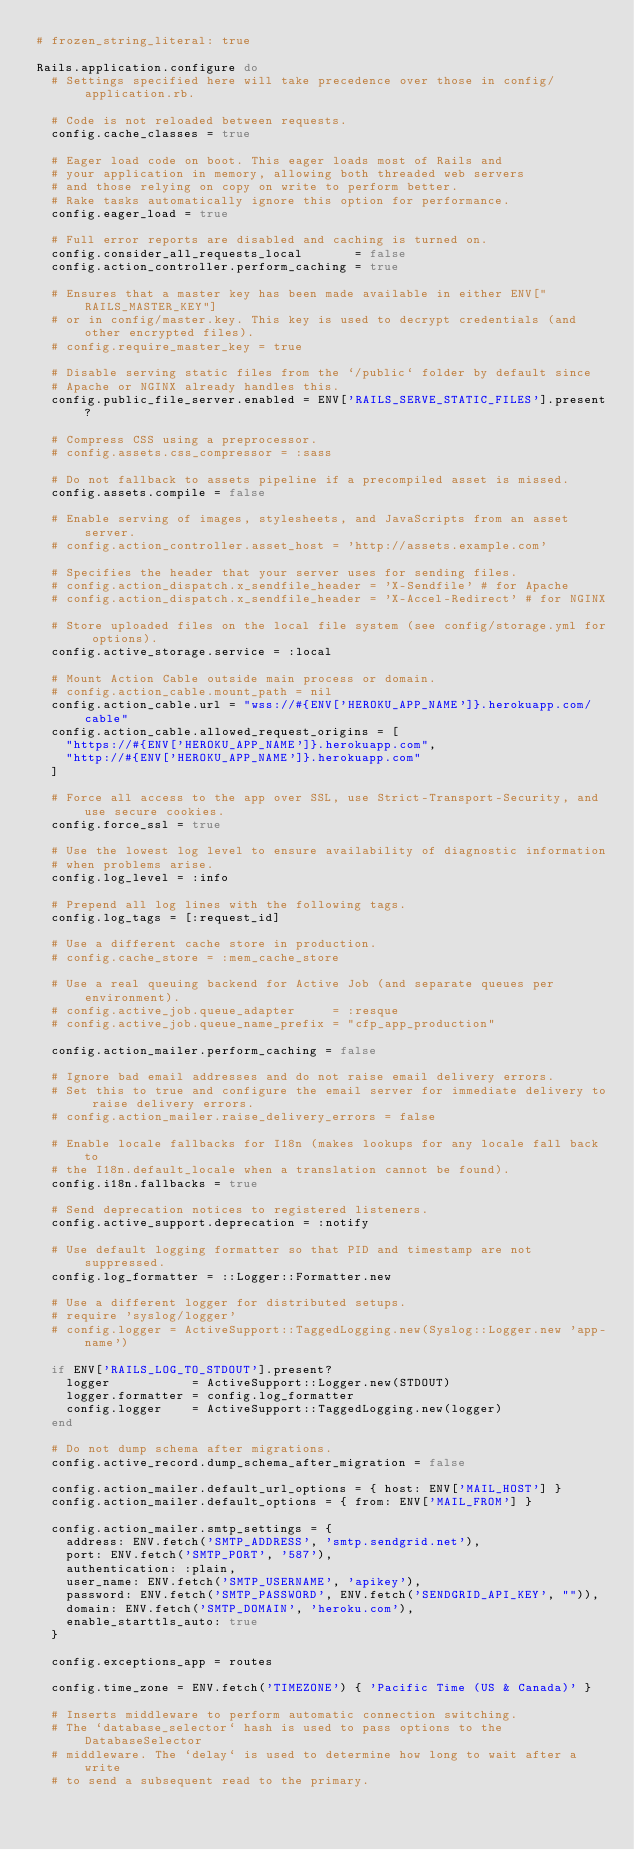Convert code to text. <code><loc_0><loc_0><loc_500><loc_500><_Ruby_># frozen_string_literal: true

Rails.application.configure do
  # Settings specified here will take precedence over those in config/application.rb.

  # Code is not reloaded between requests.
  config.cache_classes = true

  # Eager load code on boot. This eager loads most of Rails and
  # your application in memory, allowing both threaded web servers
  # and those relying on copy on write to perform better.
  # Rake tasks automatically ignore this option for performance.
  config.eager_load = true

  # Full error reports are disabled and caching is turned on.
  config.consider_all_requests_local       = false
  config.action_controller.perform_caching = true

  # Ensures that a master key has been made available in either ENV["RAILS_MASTER_KEY"]
  # or in config/master.key. This key is used to decrypt credentials (and other encrypted files).
  # config.require_master_key = true

  # Disable serving static files from the `/public` folder by default since
  # Apache or NGINX already handles this.
  config.public_file_server.enabled = ENV['RAILS_SERVE_STATIC_FILES'].present?

  # Compress CSS using a preprocessor.
  # config.assets.css_compressor = :sass

  # Do not fallback to assets pipeline if a precompiled asset is missed.
  config.assets.compile = false

  # Enable serving of images, stylesheets, and JavaScripts from an asset server.
  # config.action_controller.asset_host = 'http://assets.example.com'

  # Specifies the header that your server uses for sending files.
  # config.action_dispatch.x_sendfile_header = 'X-Sendfile' # for Apache
  # config.action_dispatch.x_sendfile_header = 'X-Accel-Redirect' # for NGINX

  # Store uploaded files on the local file system (see config/storage.yml for options).
  config.active_storage.service = :local

  # Mount Action Cable outside main process or domain.
  # config.action_cable.mount_path = nil
  config.action_cable.url = "wss://#{ENV['HEROKU_APP_NAME']}.herokuapp.com/cable"
  config.action_cable.allowed_request_origins = [
    "https://#{ENV['HEROKU_APP_NAME']}.herokuapp.com",
    "http://#{ENV['HEROKU_APP_NAME']}.herokuapp.com"
  ]

  # Force all access to the app over SSL, use Strict-Transport-Security, and use secure cookies.
  config.force_ssl = true

  # Use the lowest log level to ensure availability of diagnostic information
  # when problems arise.
  config.log_level = :info

  # Prepend all log lines with the following tags.
  config.log_tags = [:request_id]

  # Use a different cache store in production.
  # config.cache_store = :mem_cache_store

  # Use a real queuing backend for Active Job (and separate queues per environment).
  # config.active_job.queue_adapter     = :resque
  # config.active_job.queue_name_prefix = "cfp_app_production"

  config.action_mailer.perform_caching = false

  # Ignore bad email addresses and do not raise email delivery errors.
  # Set this to true and configure the email server for immediate delivery to raise delivery errors.
  # config.action_mailer.raise_delivery_errors = false

  # Enable locale fallbacks for I18n (makes lookups for any locale fall back to
  # the I18n.default_locale when a translation cannot be found).
  config.i18n.fallbacks = true

  # Send deprecation notices to registered listeners.
  config.active_support.deprecation = :notify

  # Use default logging formatter so that PID and timestamp are not suppressed.
  config.log_formatter = ::Logger::Formatter.new

  # Use a different logger for distributed setups.
  # require 'syslog/logger'
  # config.logger = ActiveSupport::TaggedLogging.new(Syslog::Logger.new 'app-name')

  if ENV['RAILS_LOG_TO_STDOUT'].present?
    logger           = ActiveSupport::Logger.new(STDOUT)
    logger.formatter = config.log_formatter
    config.logger    = ActiveSupport::TaggedLogging.new(logger)
  end

  # Do not dump schema after migrations.
  config.active_record.dump_schema_after_migration = false

  config.action_mailer.default_url_options = { host: ENV['MAIL_HOST'] }
  config.action_mailer.default_options = { from: ENV['MAIL_FROM'] }

  config.action_mailer.smtp_settings = {
    address: ENV.fetch('SMTP_ADDRESS', 'smtp.sendgrid.net'),
    port: ENV.fetch('SMTP_PORT', '587'),
    authentication: :plain,
    user_name: ENV.fetch('SMTP_USERNAME', 'apikey'),
    password: ENV.fetch('SMTP_PASSWORD', ENV.fetch('SENDGRID_API_KEY', "")),
    domain: ENV.fetch('SMTP_DOMAIN', 'heroku.com'),
    enable_starttls_auto: true
  }

  config.exceptions_app = routes

  config.time_zone = ENV.fetch('TIMEZONE') { 'Pacific Time (US & Canada)' }

  # Inserts middleware to perform automatic connection switching.
  # The `database_selector` hash is used to pass options to the DatabaseSelector
  # middleware. The `delay` is used to determine how long to wait after a write
  # to send a subsequent read to the primary.</code> 